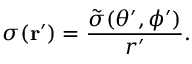Convert formula to latex. <formula><loc_0><loc_0><loc_500><loc_500>\sigma ( { r } ^ { \prime } ) = \frac { \tilde { \sigma } ( \theta ^ { \prime } , \phi ^ { \prime } ) } { r ^ { \prime } } .</formula> 